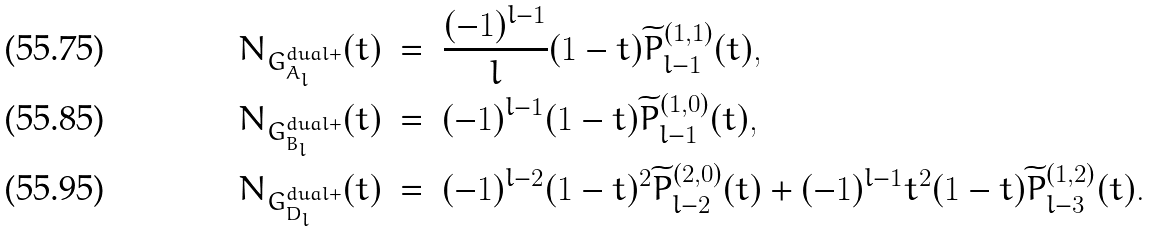Convert formula to latex. <formula><loc_0><loc_0><loc_500><loc_500>N _ { G ^ { d u a l + } _ { A _ { l } } } ( t ) & \ = \ \frac { ( - 1 ) ^ { l - 1 } } { l } ( 1 - t ) \widetilde { P } ^ { ( 1 , 1 ) } _ { l - 1 } ( t ) , \\ N _ { G ^ { d u a l + } _ { B _ { l } } } ( t ) & \ = \ ( - 1 ) ^ { l - 1 } ( 1 - t ) \widetilde { P } ^ { ( 1 , 0 ) } _ { l - 1 } ( t ) , \\ N _ { G ^ { d u a l + } _ { D _ { l } } } ( t ) & \ = \ ( - 1 ) ^ { l - 2 } ( 1 - t ) ^ { 2 } \widetilde { P } ^ { ( 2 , 0 ) } _ { l - 2 } ( t ) + ( - 1 ) ^ { l - 1 } t ^ { 2 } ( 1 - t ) \widetilde { P } ^ { ( 1 , 2 ) } _ { l - 3 } ( t ) .</formula> 